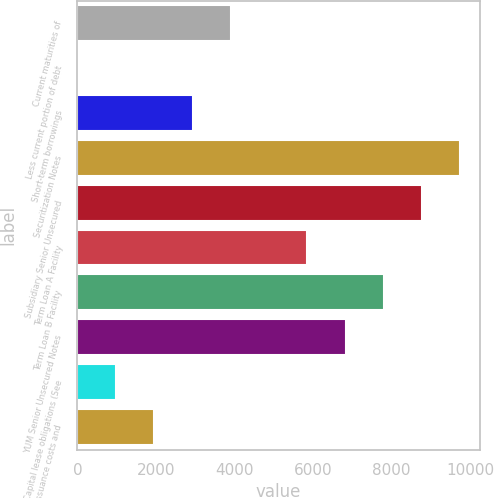Convert chart to OTSL. <chart><loc_0><loc_0><loc_500><loc_500><bar_chart><fcel>Current maturities of<fcel>Less current portion of debt<fcel>Short-term borrowings<fcel>Securitization Notes<fcel>Subsidiary Senior Unsecured<fcel>Term Loan A Facility<fcel>Term Loan B Facility<fcel>YUM Senior Unsecured Notes<fcel>Capital lease obligations (See<fcel>Less debt issuance costs and<nl><fcel>3906.4<fcel>10<fcel>2932.3<fcel>9751<fcel>8776.9<fcel>5854.6<fcel>7802.8<fcel>6828.7<fcel>984.1<fcel>1958.2<nl></chart> 